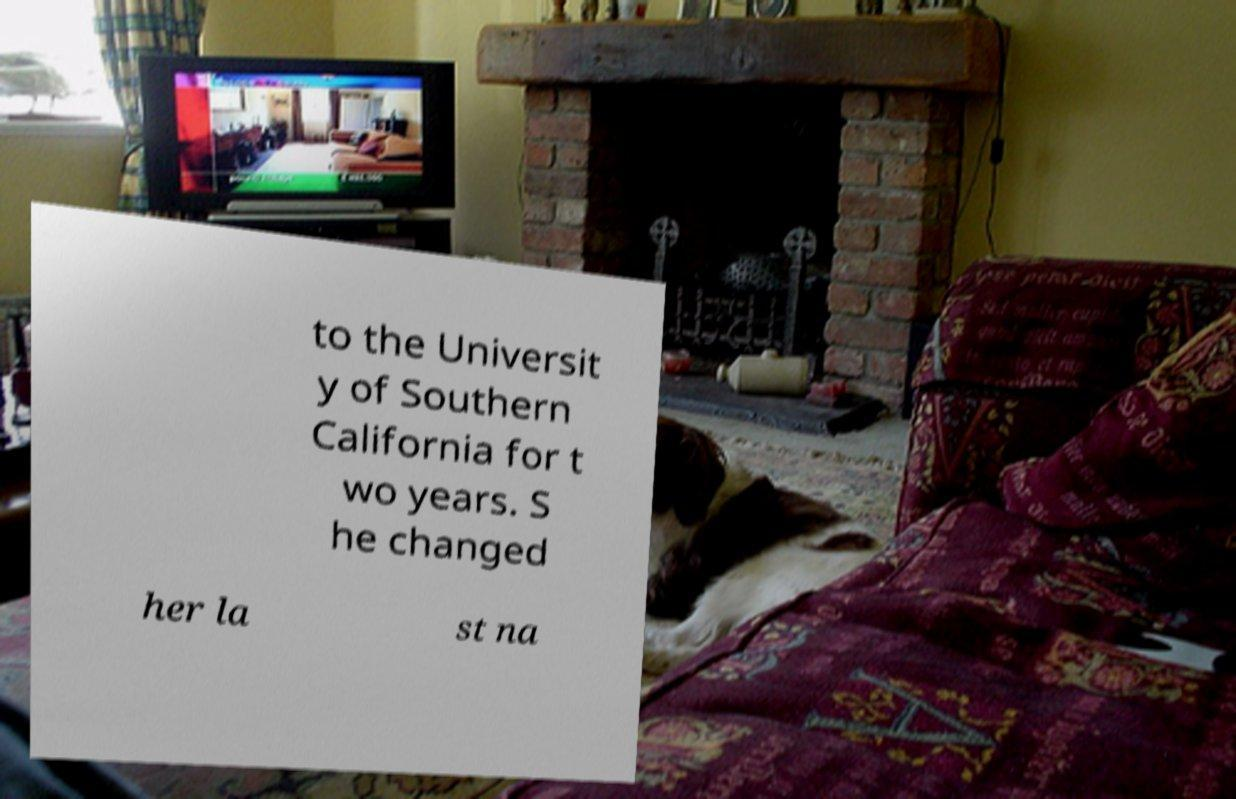Please read and relay the text visible in this image. What does it say? to the Universit y of Southern California for t wo years. S he changed her la st na 